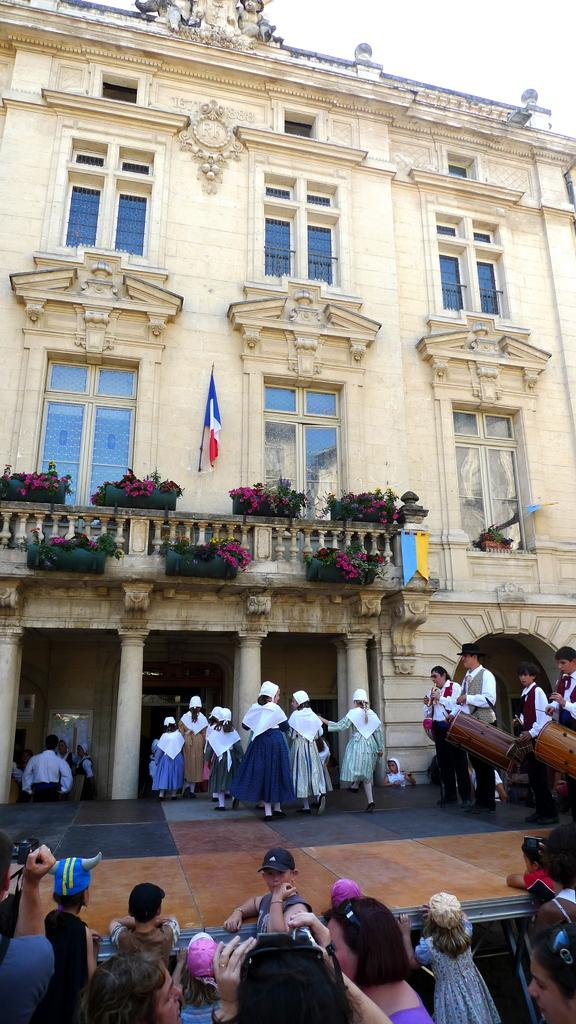What type of structure is present in the image? There is a building in the image. What other elements can be seen in the image besides the building? There are plants and flowers in the image. What feature of the building is mentioned in the facts? The building has windows. Are there any living beings visible in the image? Yes, there are people visible in the image. What part of the natural environment can be seen in the image? The sky is visible in the image. What type of bike can be seen leaning against the building in the image? There is no bike present in the image; it only features a building, plants, flowers, windows, people, and the sky. 